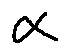Convert formula to latex. <formula><loc_0><loc_0><loc_500><loc_500>\alpha</formula> 